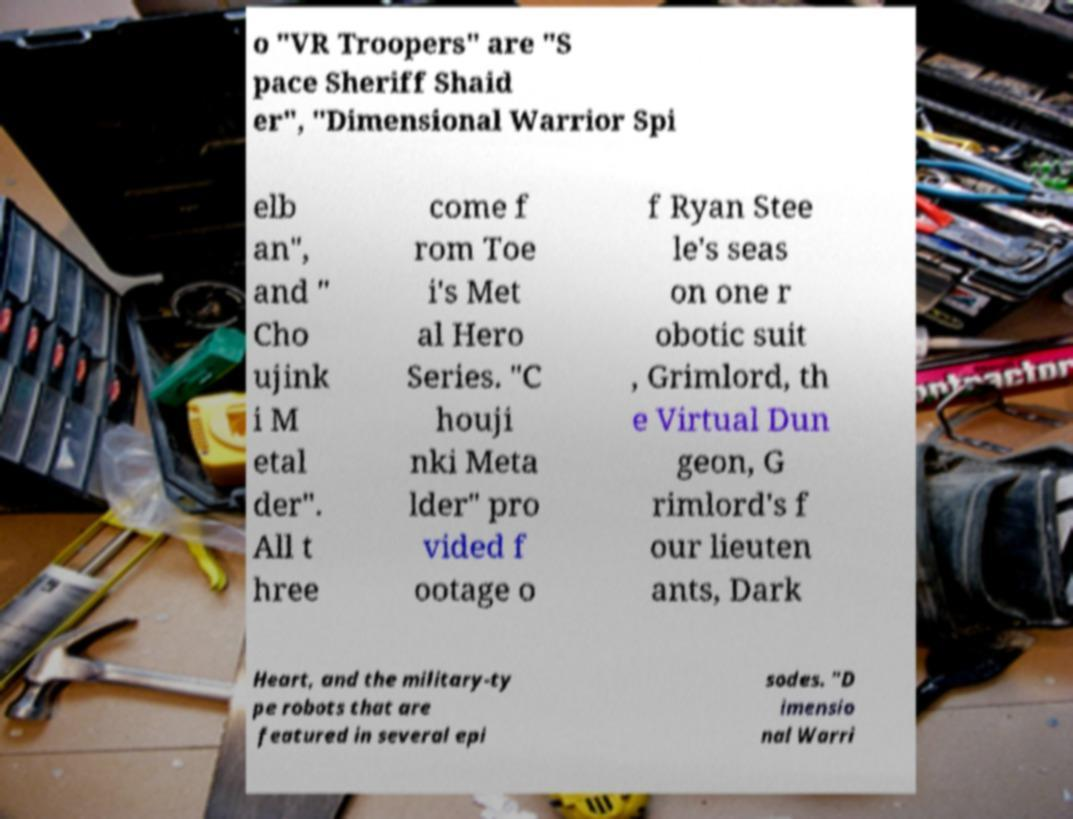What messages or text are displayed in this image? I need them in a readable, typed format. o "VR Troopers" are "S pace Sheriff Shaid er", "Dimensional Warrior Spi elb an", and " Cho ujink i M etal der". All t hree come f rom Toe i's Met al Hero Series. "C houji nki Meta lder" pro vided f ootage o f Ryan Stee le's seas on one r obotic suit , Grimlord, th e Virtual Dun geon, G rimlord's f our lieuten ants, Dark Heart, and the military-ty pe robots that are featured in several epi sodes. "D imensio nal Warri 